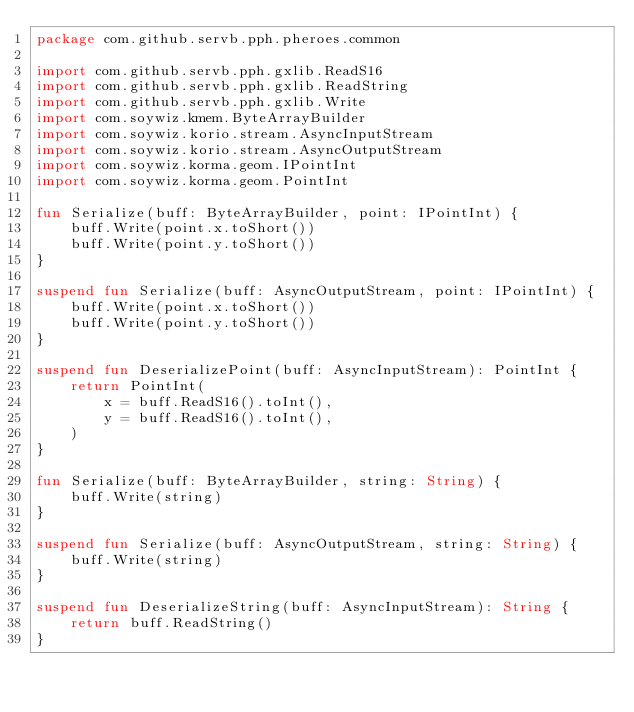Convert code to text. <code><loc_0><loc_0><loc_500><loc_500><_Kotlin_>package com.github.servb.pph.pheroes.common

import com.github.servb.pph.gxlib.ReadS16
import com.github.servb.pph.gxlib.ReadString
import com.github.servb.pph.gxlib.Write
import com.soywiz.kmem.ByteArrayBuilder
import com.soywiz.korio.stream.AsyncInputStream
import com.soywiz.korio.stream.AsyncOutputStream
import com.soywiz.korma.geom.IPointInt
import com.soywiz.korma.geom.PointInt

fun Serialize(buff: ByteArrayBuilder, point: IPointInt) {
    buff.Write(point.x.toShort())
    buff.Write(point.y.toShort())
}

suspend fun Serialize(buff: AsyncOutputStream, point: IPointInt) {
    buff.Write(point.x.toShort())
    buff.Write(point.y.toShort())
}

suspend fun DeserializePoint(buff: AsyncInputStream): PointInt {
    return PointInt(
        x = buff.ReadS16().toInt(),
        y = buff.ReadS16().toInt(),
    )
}

fun Serialize(buff: ByteArrayBuilder, string: String) {
    buff.Write(string)
}

suspend fun Serialize(buff: AsyncOutputStream, string: String) {
    buff.Write(string)
}

suspend fun DeserializeString(buff: AsyncInputStream): String {
    return buff.ReadString()
}
</code> 